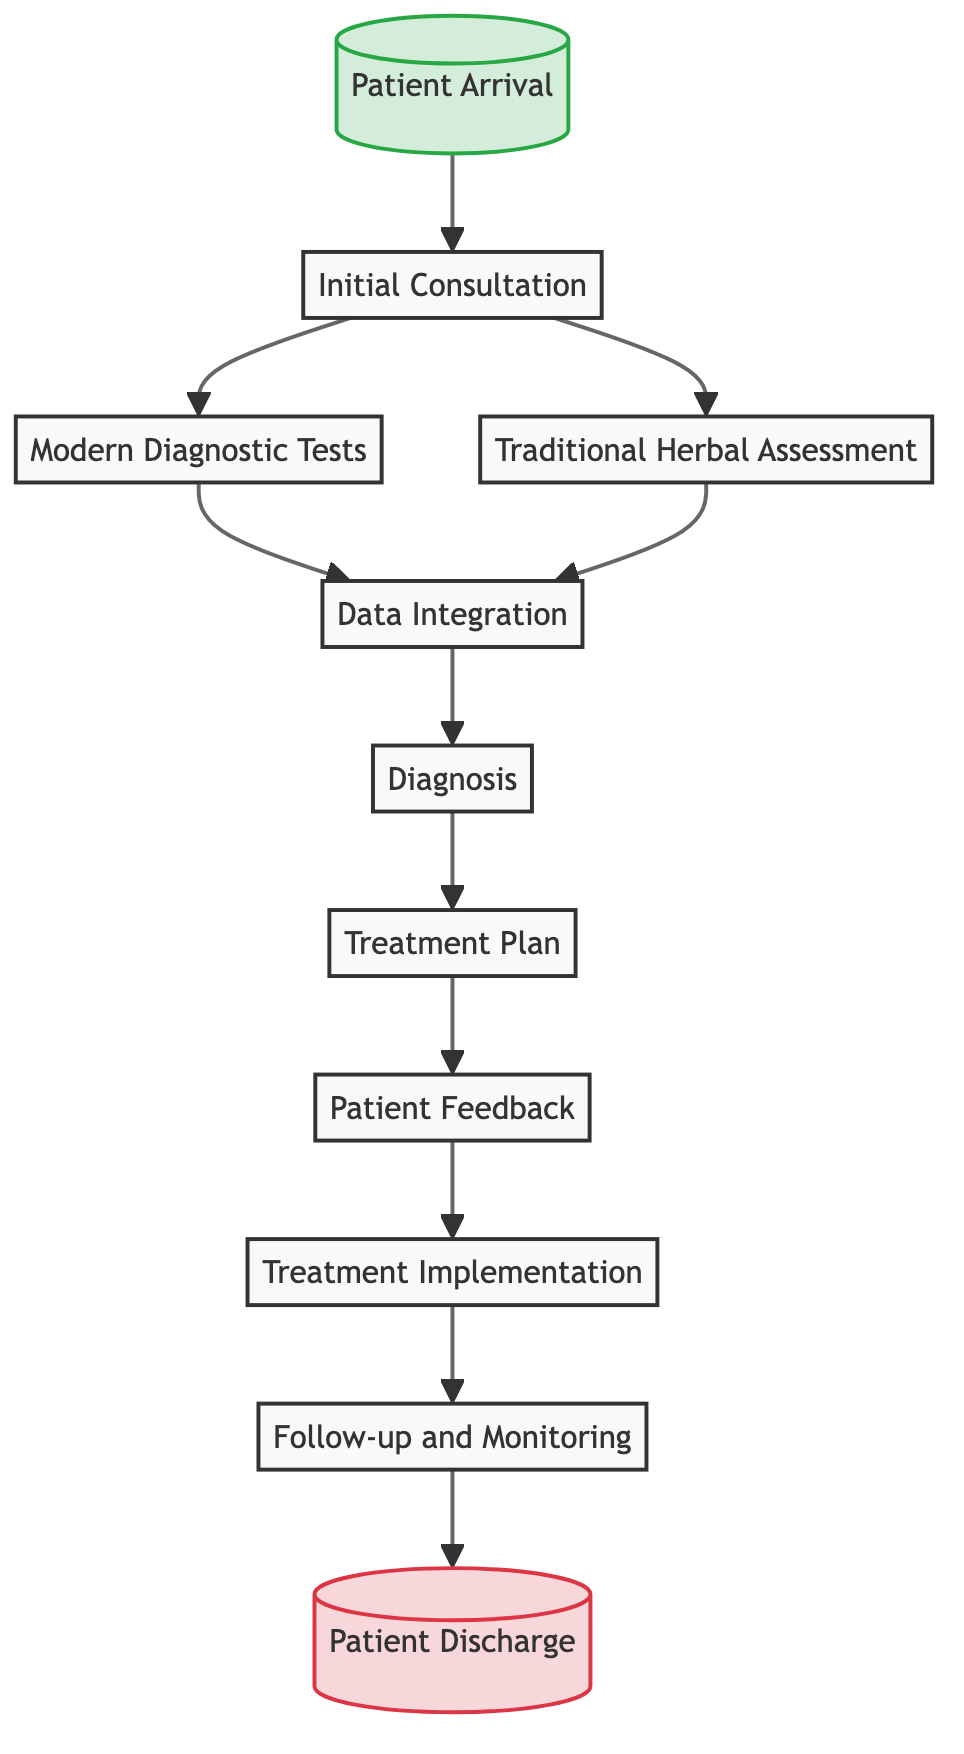What is the first step in the workflow? The first step is labeled "Patient Arrival," indicating that the process begins with the patient arriving at the clinic and registering for their appointment.
Answer: Patient Arrival How many types of assessments are conducted during the initial consultation? During the initial consultation, both "Modern Diagnostic Tests" and "Traditional Herbal Assessment" occur, making a total of two types of assessments.
Answer: Two What step follows "Data Integration"? The step that follows "Data Integration" is "Diagnosis," where a diagnosis is formulated based on the integrated analysis of results.
Answer: Diagnosis Which node represents the exit point of the workflow? The exit point is labeled "Patient Discharge," indicating the conclusion of the workflow once treatment goals are achieved.
Answer: Patient Discharge What does the "Treatment Plan" step involve? The "Treatment Plan" step involves developing a plan that may include modern medical treatments, traditional herbal remedies, or a combination of both, based on the diagnosis.
Answer: Developing a treatment plan Which two nodes are connected directly to "Initial Consultation"? "Modern Diagnostic Tests" and "Traditional Herbal Assessment" both connect directly to "Initial Consultation," indicating that both assessments arise from the initial consultation step.
Answer: Modern Diagnostic Tests and Traditional Herbal Assessment What is the last step before patient discharge? The last step before patient discharge is "Follow-up and Monitoring," where the patient's progress is monitored through follow-up consultations.
Answer: Follow-up and Monitoring What type of analysis is involved in the "Data Integration" step? The "Data Integration" step involves a comprehensive analysis that combines results from both modern medical tests and traditional assessments.
Answer: Comprehensive analysis What action is taken after "Patient Feedback"? After gathering "Patient Feedback," the next action taken is "Treatment Implementation," where the agreed-upon treatment plan is implemented.
Answer: Treatment Implementation 